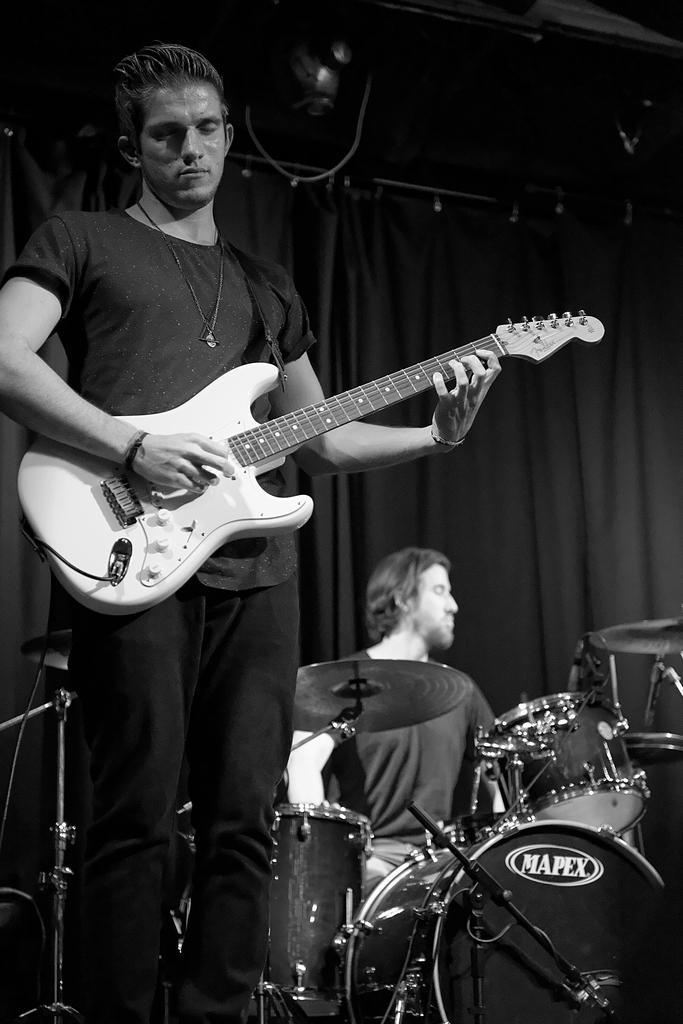Describe this image in one or two sentences. In this picture there is a person who is holding a guitar and behind there is a man who is playing a musical instrument. 